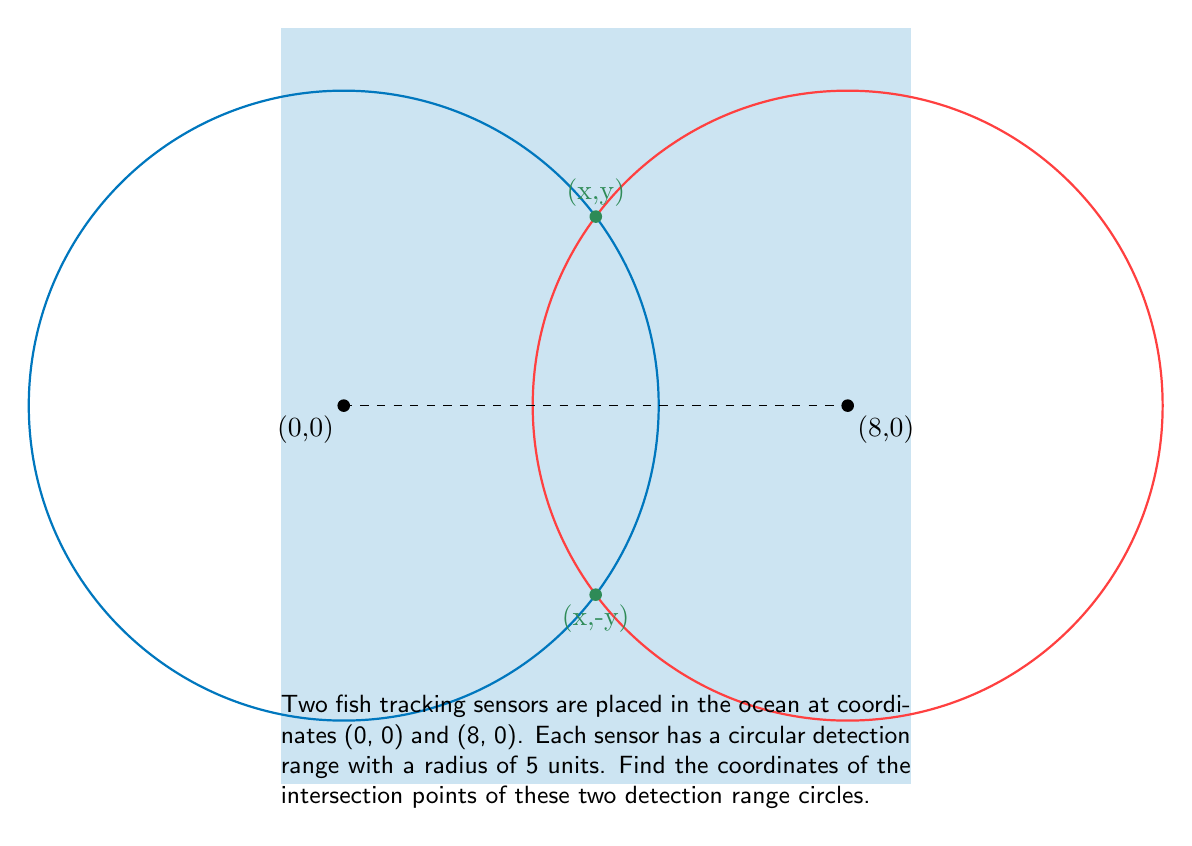Can you answer this question? Let's solve this step-by-step:

1) The equations of the two circles are:
   Circle 1 (centered at (0,0)): $x^2 + y^2 = 25$
   Circle 2 (centered at (8,0)): $(x-8)^2 + y^2 = 25$

2) To find the intersection points, we need to solve these equations simultaneously.

3) Expanding the second equation:
   $x^2 - 16x + 64 + y^2 = 25$

4) Subtracting the first equation from this:
   $-16x + 64 = 0$

5) Solving for x:
   $-16x = -64$
   $x = 4$

6) Substituting this back into the equation of the first circle:
   $4^2 + y^2 = 25$
   $16 + y^2 = 25$
   $y^2 = 9$
   $y = \pm 3$

7) Therefore, the intersection points are (4, 3) and (4, -3).

8) We can verify these satisfy both circle equations:
   For (4, 3): $4^2 + 3^2 = 25$ and $(4-8)^2 + 3^2 = 25$
   For (4, -3): $4^2 + (-3)^2 = 25$ and $(4-8)^2 + (-3)^2 = 25$
Answer: (4, 3) and (4, -3) 